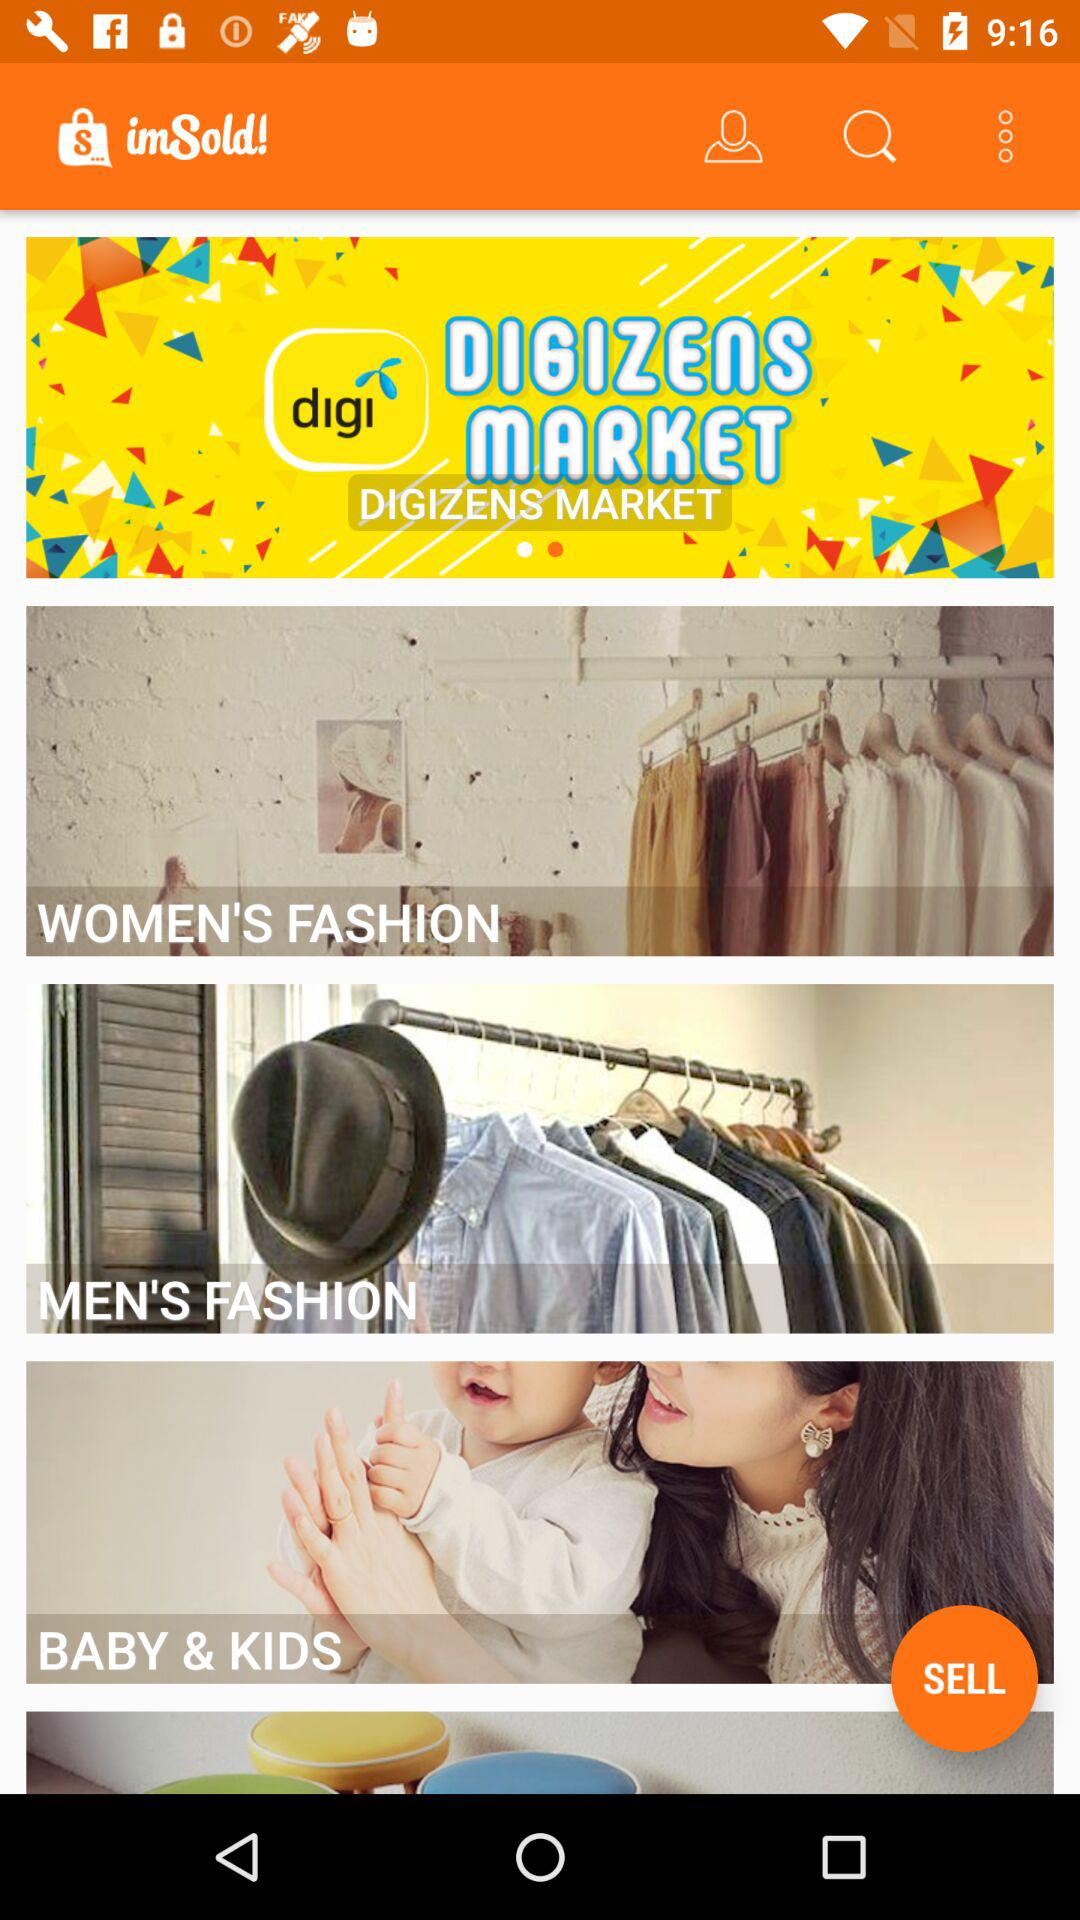What is the application name? The application name is "imSold!". 